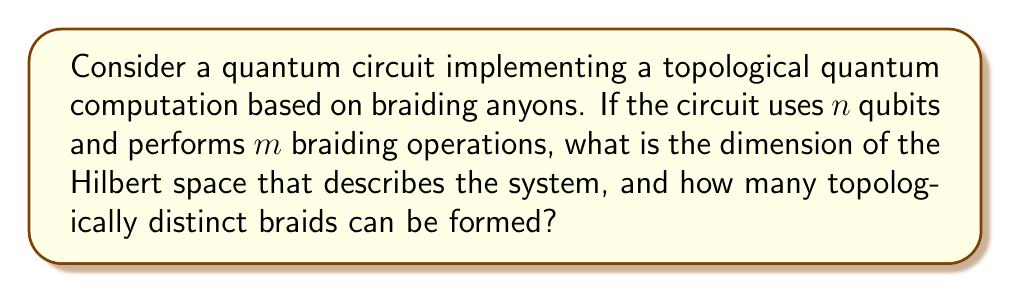Show me your answer to this math problem. To solve this problem, we need to consider the principles of quantum computing and knot theory:

1. Hilbert space dimension:
   In quantum computing, the dimension of the Hilbert space for $n$ qubits is given by $2^n$. This is because each qubit can be in a superposition of two states (0 and 1), and the total number of possible states grows exponentially with the number of qubits.

2. Topologically distinct braids:
   In knot theory, the number of topologically distinct braids with $m$ crossings on $n$ strands is related to the braid group $B_n$. However, not all braids are topologically distinct when considering their closure.

   The upper bound for the number of topologically distinct braids is given by the expression:

   $$ N_{braids} \leq (n-1)^m $$

   This is because at each crossing, we have $(n-1)$ choices for which adjacent strands to braid, and we perform this $m$ times.

Therefore, the solution to this problem involves two parts:

a) The dimension of the Hilbert space:
   $$ \text{dim}(H) = 2^n $$

b) The upper bound on the number of topologically distinct braids:
   $$ N_{braids} \leq (n-1)^m $$

It's important to note that this upper bound is often an overestimate, as many braids may be equivalent under topological moves. The actual number of distinct braids depends on the specific rules of the topological quantum computation model being used.
Answer: The dimension of the Hilbert space is $2^n$, and the upper bound on the number of topologically distinct braids is $(n-1)^m$. 